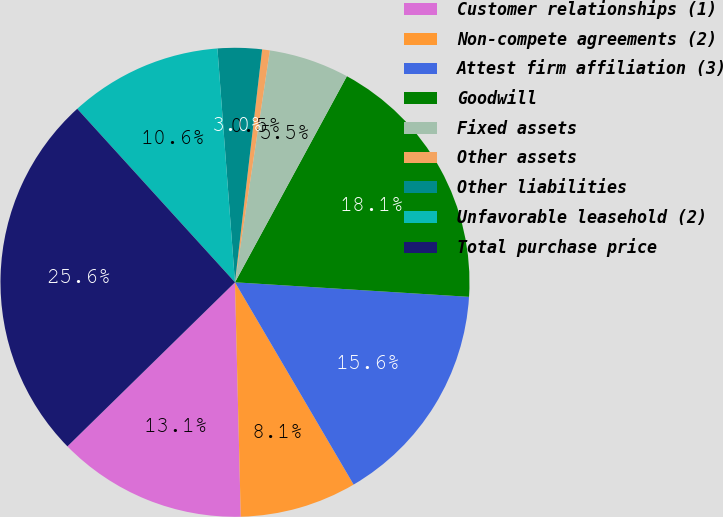Convert chart. <chart><loc_0><loc_0><loc_500><loc_500><pie_chart><fcel>Customer relationships (1)<fcel>Non-compete agreements (2)<fcel>Attest firm affiliation (3)<fcel>Goodwill<fcel>Fixed assets<fcel>Other assets<fcel>Other liabilities<fcel>Unfavorable leasehold (2)<fcel>Total purchase price<nl><fcel>13.06%<fcel>8.05%<fcel>15.57%<fcel>18.07%<fcel>5.54%<fcel>0.53%<fcel>3.04%<fcel>10.55%<fcel>25.59%<nl></chart> 